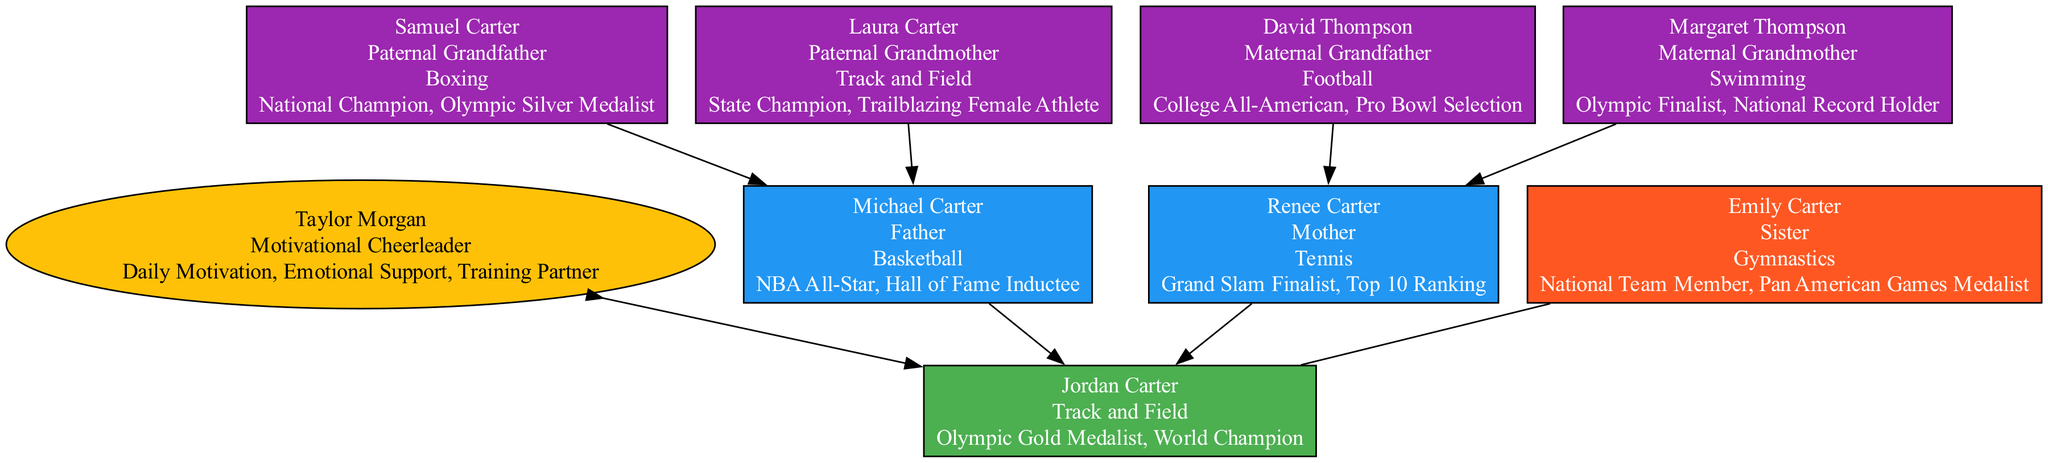What is the sport of Jordan Carter? Jordan Carter is depicted at the top of the diagram, and it states that his sport is Track and Field.
Answer: Track and Field Who is the motivational cheerleader for Jordan Carter? Looking at the support section of the diagram, Taylor Morgan is identified as the motivational cheerleader for Jordan Carter.
Answer: Taylor Morgan How many grandparents are listed in the family tree? The grandparents’ section reveals there are four individuals listed: Samuel Carter, Laura Carter, David Thompson, and Margaret Thompson.
Answer: Four What sport did Michael Carter play? In the list of parents, Michael Carter is noted for playing Basketball.
Answer: Basketball Which achievement is associated with Laura Carter? The diagram states that Laura Carter is recognized as a State Champion and a Trailblazing Female Athlete in her sport, Track and Field.
Answer: State Champion What influence did Renee Carter have on Jordan's athletic journey? The influence listed for Renee Carter includes Discipline and Work Ethic, which played a role in shaping Jordan's approach to sports.
Answer: Discipline, Work Ethic Who is Emily Carter's relation to Jordan Carter? The diagram shows that Emily Carter is labeled as Jordan Carter's sister.
Answer: Sister Which sports did Jordan Carter's maternal grandparents play? The maternal grandparents, David Thompson and Margaret Thompson, are associated with Football and Swimming, respectively.
Answer: Football, Swimming What achievement is shared between both of Jordan's grandfathers? Samuel Carter and David Thompson are both recognized for their achievements: Boxer and Footballer, but none is explicitly shared; thus the answer remains that each has individual accolades.
Answer: None 